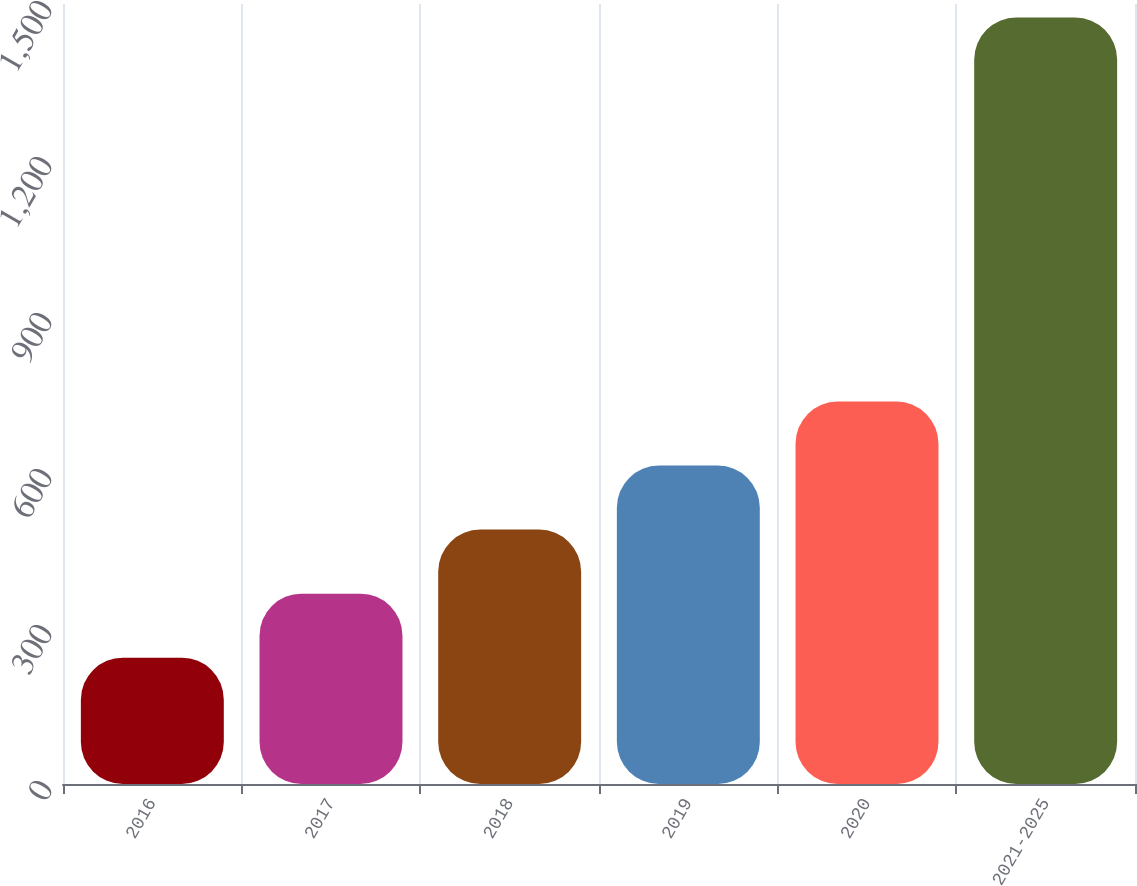Convert chart. <chart><loc_0><loc_0><loc_500><loc_500><bar_chart><fcel>2016<fcel>2017<fcel>2018<fcel>2019<fcel>2020<fcel>2021-2025<nl><fcel>243<fcel>366.1<fcel>489.2<fcel>612.3<fcel>735.4<fcel>1474<nl></chart> 